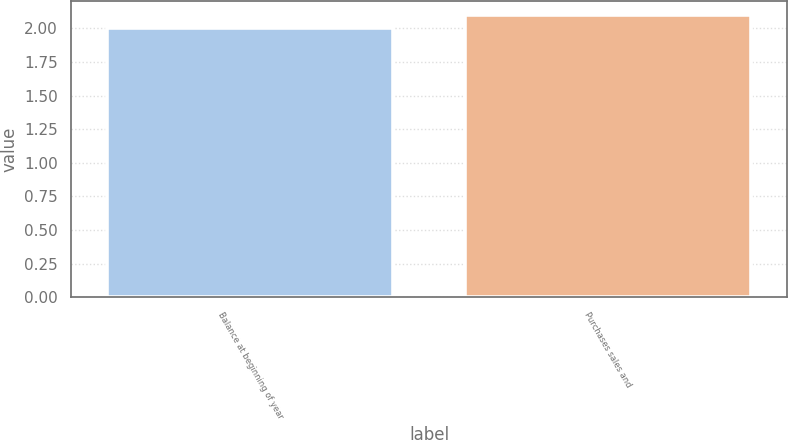Convert chart. <chart><loc_0><loc_0><loc_500><loc_500><bar_chart><fcel>Balance at beginning of year<fcel>Purchases sales and<nl><fcel>2<fcel>2.1<nl></chart> 